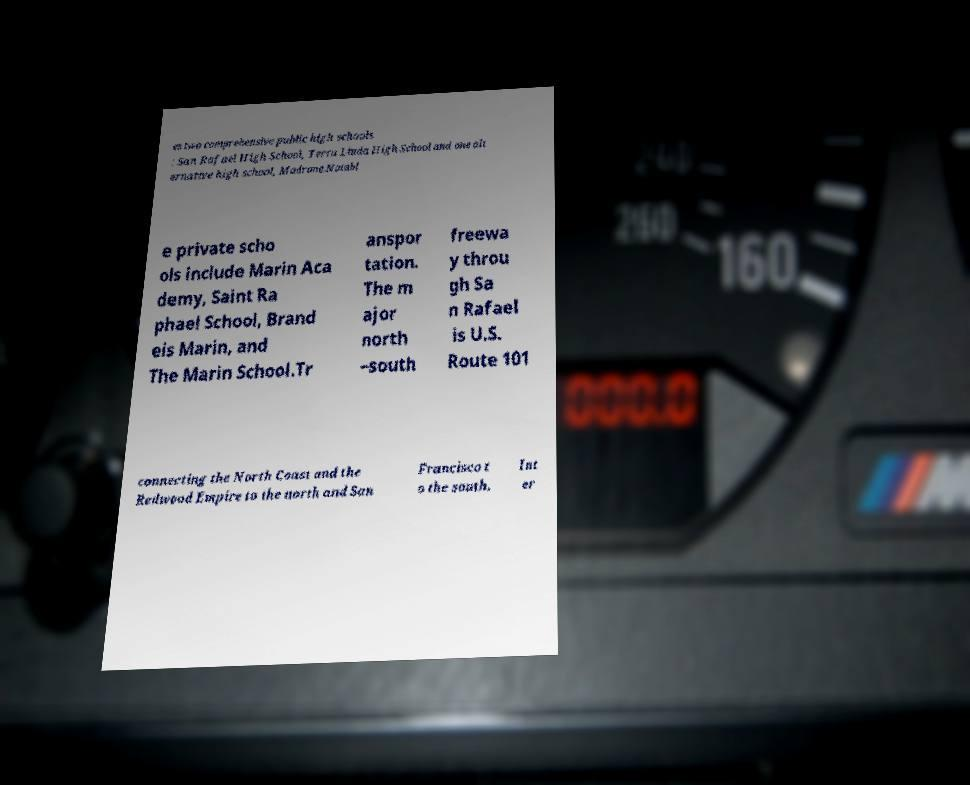Can you accurately transcribe the text from the provided image for me? es two comprehensive public high schools : San Rafael High School, Terra Linda High School and one alt ernative high school, Madrone.Notabl e private scho ols include Marin Aca demy, Saint Ra phael School, Brand eis Marin, and The Marin School.Tr anspor tation. The m ajor north –south freewa y throu gh Sa n Rafael is U.S. Route 101 connecting the North Coast and the Redwood Empire to the north and San Francisco t o the south. Int er 